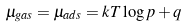Convert formula to latex. <formula><loc_0><loc_0><loc_500><loc_500>\mu _ { g a s } = \mu _ { a d s } = k T \log p + q</formula> 